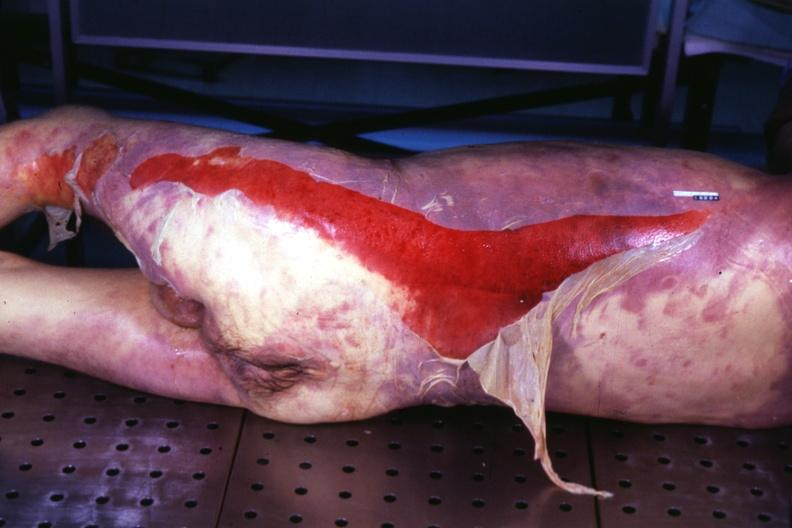where is this?
Answer the question using a single word or phrase. Skin 